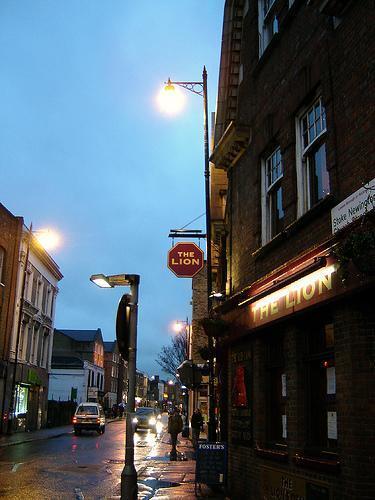How many cars are visible?
Give a very brief answer. 2. How many street lights are lit?
Give a very brief answer. 4. How many people walking the sidewalk?
Give a very brief answer. 2. 